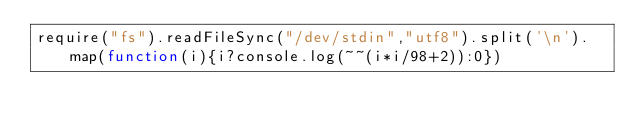Convert code to text. <code><loc_0><loc_0><loc_500><loc_500><_JavaScript_>require("fs").readFileSync("/dev/stdin","utf8").split('\n').map(function(i){i?console.log(~~(i*i/98+2)):0})</code> 